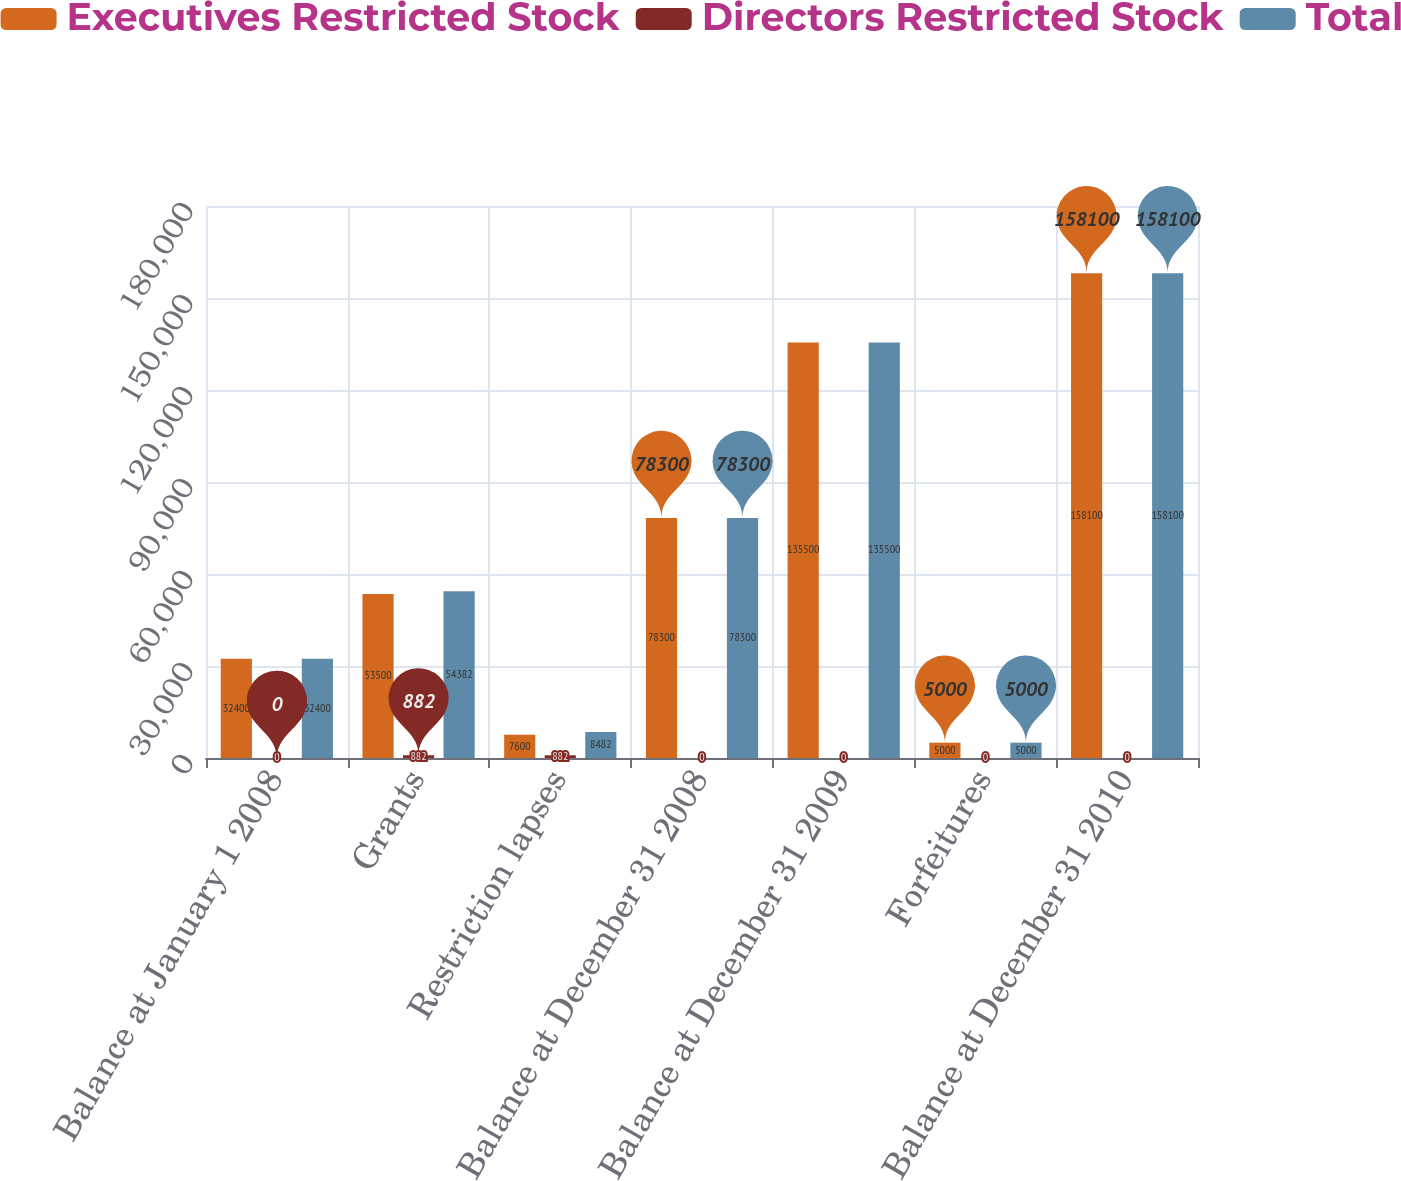Convert chart to OTSL. <chart><loc_0><loc_0><loc_500><loc_500><stacked_bar_chart><ecel><fcel>Balance at January 1 2008<fcel>Grants<fcel>Restriction lapses<fcel>Balance at December 31 2008<fcel>Balance at December 31 2009<fcel>Forfeitures<fcel>Balance at December 31 2010<nl><fcel>Executives Restricted Stock<fcel>32400<fcel>53500<fcel>7600<fcel>78300<fcel>135500<fcel>5000<fcel>158100<nl><fcel>Directors Restricted Stock<fcel>0<fcel>882<fcel>882<fcel>0<fcel>0<fcel>0<fcel>0<nl><fcel>Total<fcel>32400<fcel>54382<fcel>8482<fcel>78300<fcel>135500<fcel>5000<fcel>158100<nl></chart> 